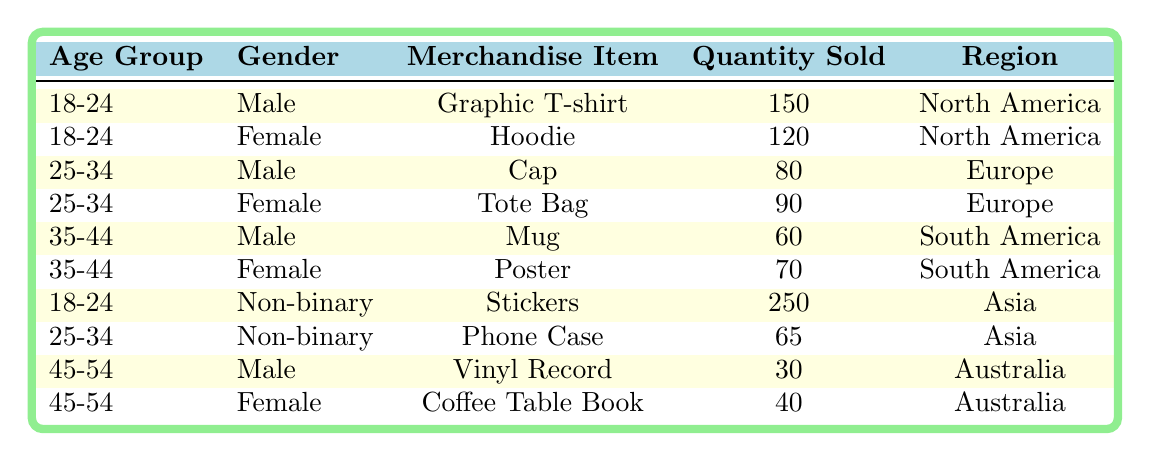What is the quantity of Graphic T-shirts sold? The table shows that for the age group 18-24 and gender Male, the quantity sold of Graphic T-shirts is 150.
Answer: 150 Which merchandise item had the highest sales in Asia? In the table, looking at the region Asia, the item with the highest quantity sold is Stickers, with 250 units sold by Non-binary individuals in the age group 18-24.
Answer: Stickers How many total items were sold to Non-binary individuals? For Non-binary individuals, the total quantity sold is the sum of Stickers (250) and Phone Case (65). So, 250 + 65 = 315.
Answer: 315 Is the quantity of Hoodies sold greater than that of Tote Bags? The quantity of Hoodies sold is 120, while Tote Bags sold are 90. Since 120 is greater than 90, the statement is true.
Answer: Yes What is the average quantity sold for merchandise items in the age group 25-34? For age group 25-34, the quantities sold are Cap (80) and Tote Bag (90) for Male and Female, respectively. The sum is 80 + 90 = 170 and the average is 170 divided by 2, which equals 85.
Answer: 85 Which gender sold more merchandise items, Male or Female, in North America? In North America, Male sold 150 Graphic T-shirts, and Female sold 120 Hoodies. Males sold more merchandise by 30 items (150 - 120 = 30).
Answer: Male How many more items did Non-binary individuals sell in Asia compared to Male individuals in South America? In Asia, Non-binary individuals sold 315 items (250 Stickers + 65 Phone Cases). Male individuals in South America sold 60 items (Mug). Therefore, 315 - 60 = 255 more items were sold by Non-binary individuals in Asia.
Answer: 255 Did more than 200 items sell in total for ages 35-44? The total for ages 35-44 is 60 (Mug) + 70 (Poster) = 130, which is less than 200, so the statement is false.
Answer: No How many items were sold in total across all categories? Summing all quantities: 150 (Graphic T-shirt) + 120 (Hoodie) + 80 (Cap) + 90 (Tote Bag) + 60 (Mug) + 70 (Poster) + 250 (Stickers) + 65 (Phone Case) + 30 (Vinyl Record) + 40 (Coffee Table Book) gives a total of 1,005 items sold.
Answer: 1005 